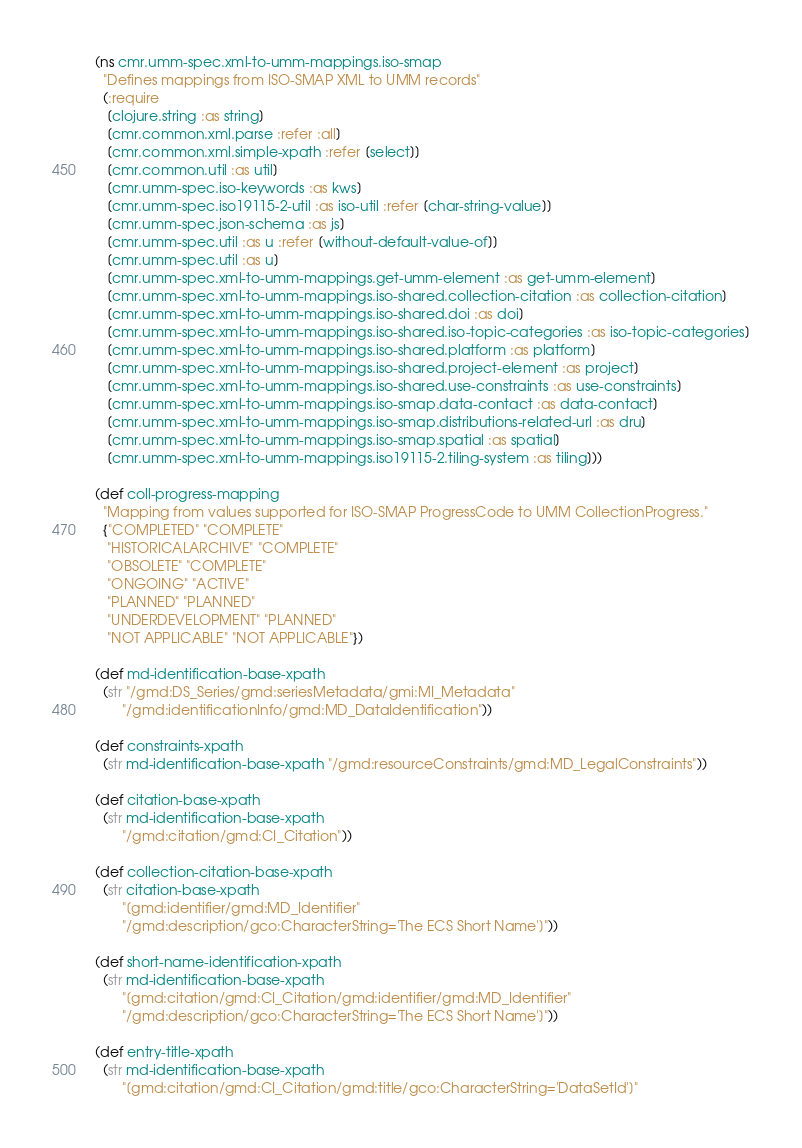<code> <loc_0><loc_0><loc_500><loc_500><_Clojure_>(ns cmr.umm-spec.xml-to-umm-mappings.iso-smap
  "Defines mappings from ISO-SMAP XML to UMM records"
  (:require
   [clojure.string :as string]
   [cmr.common.xml.parse :refer :all]
   [cmr.common.xml.simple-xpath :refer [select]]
   [cmr.common.util :as util]
   [cmr.umm-spec.iso-keywords :as kws]
   [cmr.umm-spec.iso19115-2-util :as iso-util :refer [char-string-value]]
   [cmr.umm-spec.json-schema :as js]
   [cmr.umm-spec.util :as u :refer [without-default-value-of]]
   [cmr.umm-spec.util :as u]
   [cmr.umm-spec.xml-to-umm-mappings.get-umm-element :as get-umm-element]
   [cmr.umm-spec.xml-to-umm-mappings.iso-shared.collection-citation :as collection-citation]
   [cmr.umm-spec.xml-to-umm-mappings.iso-shared.doi :as doi]
   [cmr.umm-spec.xml-to-umm-mappings.iso-shared.iso-topic-categories :as iso-topic-categories]
   [cmr.umm-spec.xml-to-umm-mappings.iso-shared.platform :as platform]
   [cmr.umm-spec.xml-to-umm-mappings.iso-shared.project-element :as project]
   [cmr.umm-spec.xml-to-umm-mappings.iso-shared.use-constraints :as use-constraints]
   [cmr.umm-spec.xml-to-umm-mappings.iso-smap.data-contact :as data-contact]
   [cmr.umm-spec.xml-to-umm-mappings.iso-smap.distributions-related-url :as dru]
   [cmr.umm-spec.xml-to-umm-mappings.iso-smap.spatial :as spatial]
   [cmr.umm-spec.xml-to-umm-mappings.iso19115-2.tiling-system :as tiling]))

(def coll-progress-mapping
  "Mapping from values supported for ISO-SMAP ProgressCode to UMM CollectionProgress."
  {"COMPLETED" "COMPLETE"
   "HISTORICALARCHIVE" "COMPLETE"
   "OBSOLETE" "COMPLETE"
   "ONGOING" "ACTIVE"
   "PLANNED" "PLANNED"
   "UNDERDEVELOPMENT" "PLANNED"
   "NOT APPLICABLE" "NOT APPLICABLE"})

(def md-identification-base-xpath
  (str "/gmd:DS_Series/gmd:seriesMetadata/gmi:MI_Metadata"
       "/gmd:identificationInfo/gmd:MD_DataIdentification"))

(def constraints-xpath
  (str md-identification-base-xpath "/gmd:resourceConstraints/gmd:MD_LegalConstraints"))

(def citation-base-xpath
  (str md-identification-base-xpath
       "/gmd:citation/gmd:CI_Citation"))

(def collection-citation-base-xpath
  (str citation-base-xpath
       "[gmd:identifier/gmd:MD_Identifier"
       "/gmd:description/gco:CharacterString='The ECS Short Name']"))

(def short-name-identification-xpath
  (str md-identification-base-xpath
       "[gmd:citation/gmd:CI_Citation/gmd:identifier/gmd:MD_Identifier"
       "/gmd:description/gco:CharacterString='The ECS Short Name']"))

(def entry-title-xpath
  (str md-identification-base-xpath
       "[gmd:citation/gmd:CI_Citation/gmd:title/gco:CharacterString='DataSetId']"</code> 